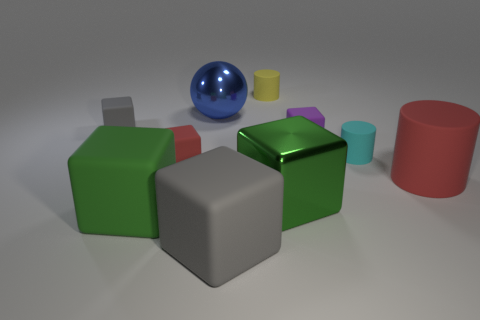What number of objects are red matte things left of the metal sphere or things that are behind the green rubber thing? After carefully examining the positions of the objects with respect to the metal sphere and the green rubber item, it appears that there are two red matte cubes to the left of the metal sphere and a total of six objects behind the green rubber cube. This makes a total of 8 objects as previously answered. 